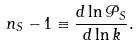<formula> <loc_0><loc_0><loc_500><loc_500>n _ { S } - 1 \equiv \frac { d \ln \mathcal { P } _ { S } } { d \ln k } .</formula> 